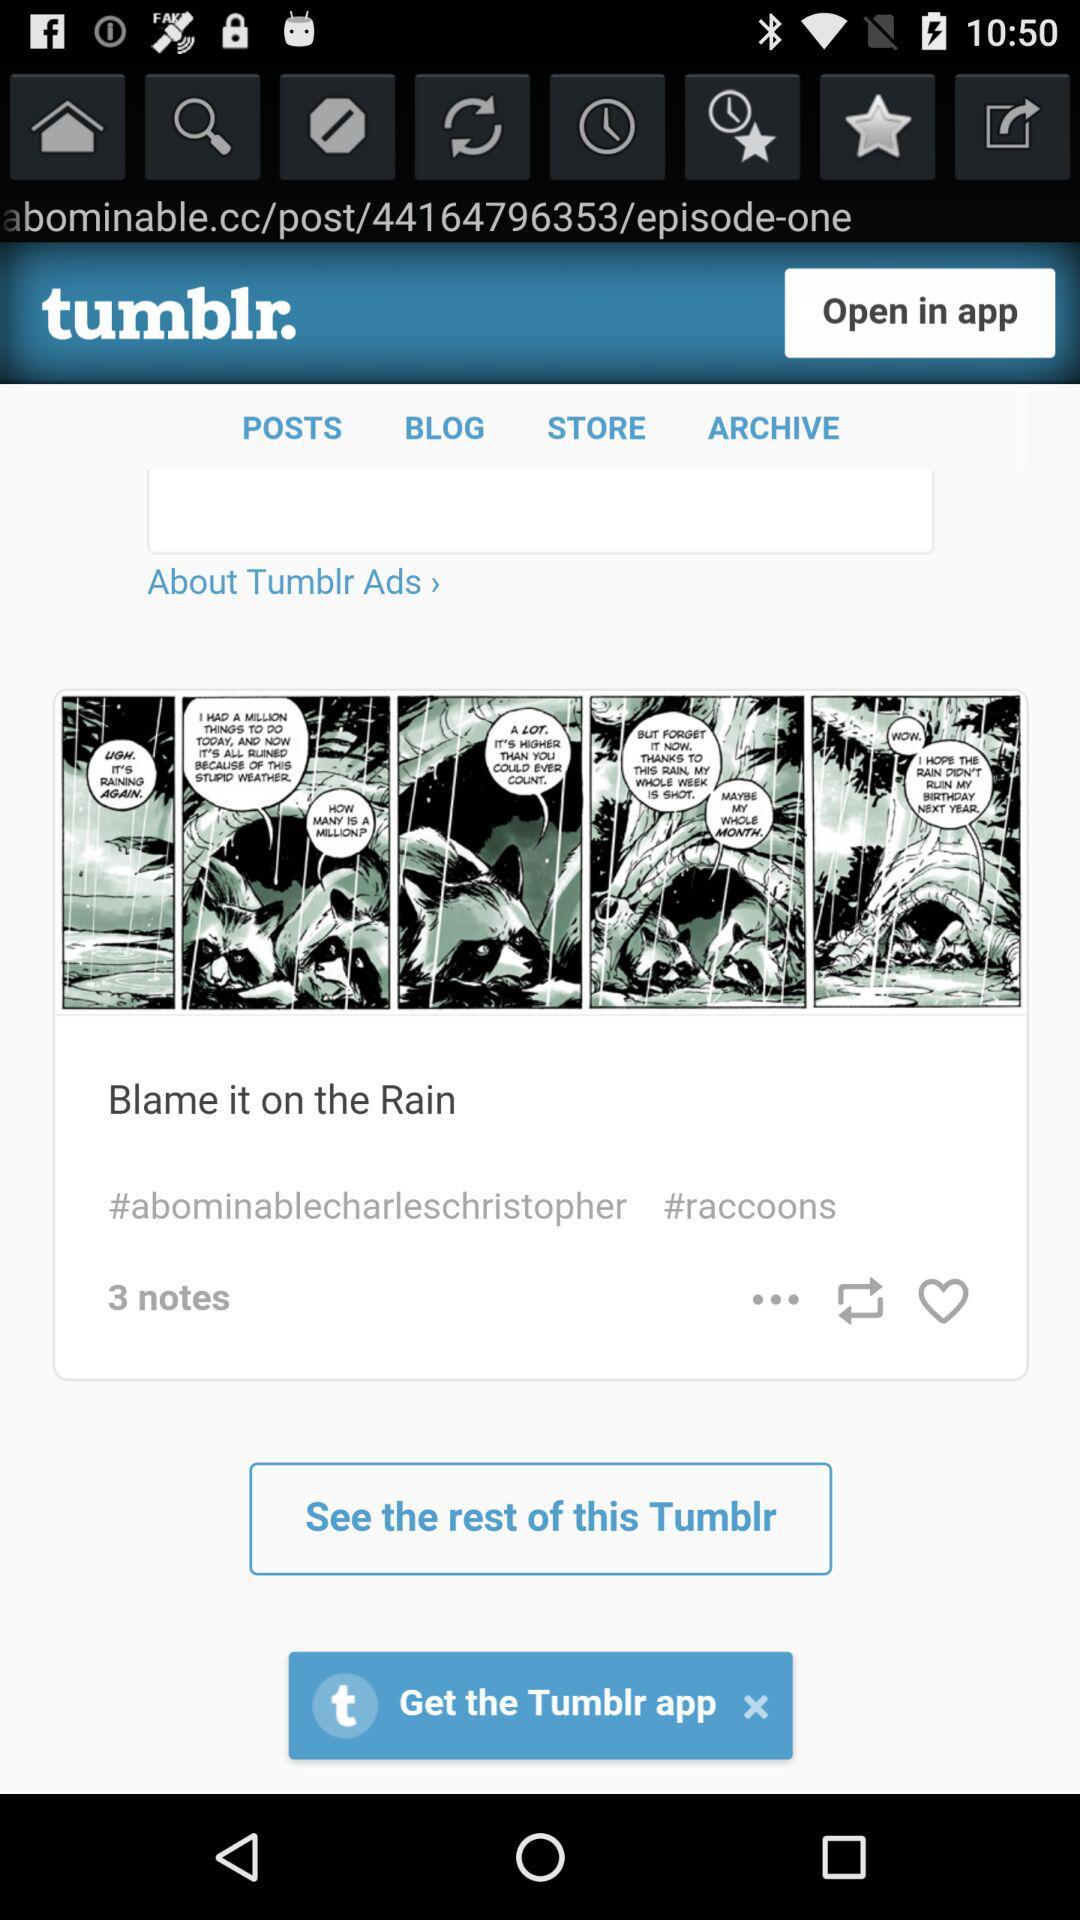How many notes are there? There are 3 notes. 